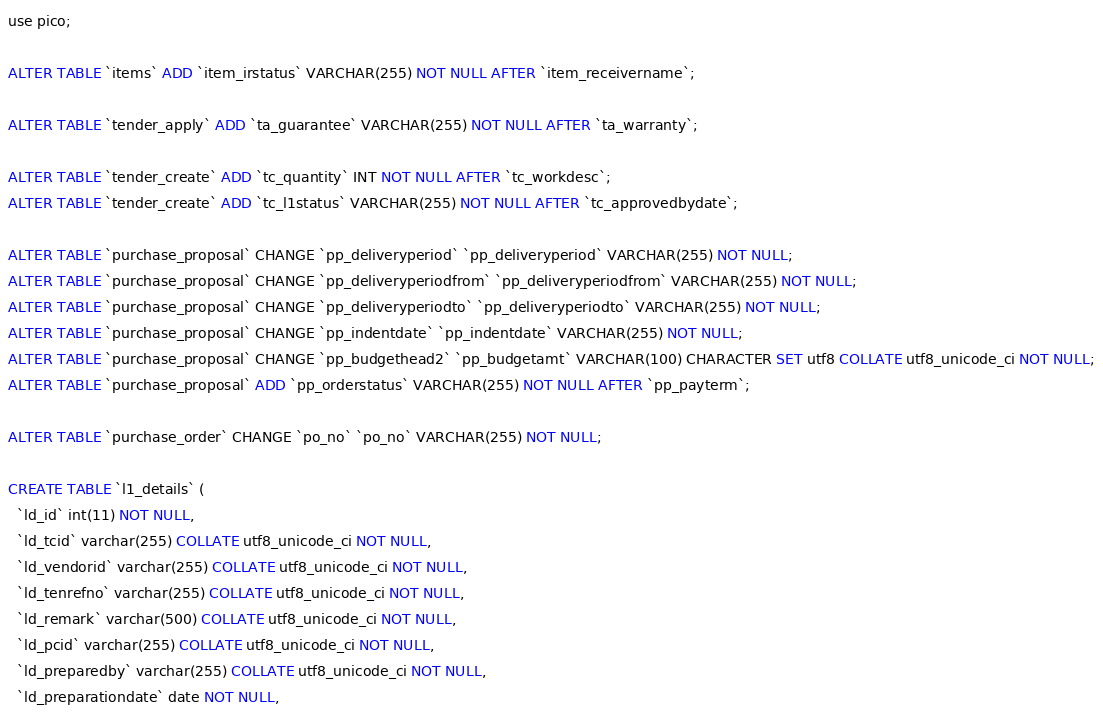Convert code to text. <code><loc_0><loc_0><loc_500><loc_500><_SQL_>use pico;

ALTER TABLE `items` ADD `item_irstatus` VARCHAR(255) NOT NULL AFTER `item_receivername`;

ALTER TABLE `tender_apply` ADD `ta_guarantee` VARCHAR(255) NOT NULL AFTER `ta_warranty`;

ALTER TABLE `tender_create` ADD `tc_quantity` INT NOT NULL AFTER `tc_workdesc`;
ALTER TABLE `tender_create` ADD `tc_l1status` VARCHAR(255) NOT NULL AFTER `tc_approvedbydate`;

ALTER TABLE `purchase_proposal` CHANGE `pp_deliveryperiod` `pp_deliveryperiod` VARCHAR(255) NOT NULL;
ALTER TABLE `purchase_proposal` CHANGE `pp_deliveryperiodfrom` `pp_deliveryperiodfrom` VARCHAR(255) NOT NULL;
ALTER TABLE `purchase_proposal` CHANGE `pp_deliveryperiodto` `pp_deliveryperiodto` VARCHAR(255) NOT NULL;
ALTER TABLE `purchase_proposal` CHANGE `pp_indentdate` `pp_indentdate` VARCHAR(255) NOT NULL;
ALTER TABLE `purchase_proposal` CHANGE `pp_budgethead2` `pp_budgetamt` VARCHAR(100) CHARACTER SET utf8 COLLATE utf8_unicode_ci NOT NULL;
ALTER TABLE `purchase_proposal` ADD `pp_orderstatus` VARCHAR(255) NOT NULL AFTER `pp_payterm`;

ALTER TABLE `purchase_order` CHANGE `po_no` `po_no` VARCHAR(255) NOT NULL;

CREATE TABLE `l1_details` (
  `ld_id` int(11) NOT NULL,
  `ld_tcid` varchar(255) COLLATE utf8_unicode_ci NOT NULL,
  `ld_vendorid` varchar(255) COLLATE utf8_unicode_ci NOT NULL,
  `ld_tenrefno` varchar(255) COLLATE utf8_unicode_ci NOT NULL,
  `ld_remark` varchar(500) COLLATE utf8_unicode_ci NOT NULL,
  `ld_pcid` varchar(255) COLLATE utf8_unicode_ci NOT NULL,
  `ld_preparedby` varchar(255) COLLATE utf8_unicode_ci NOT NULL,
  `ld_preparationdate` date NOT NULL,</code> 